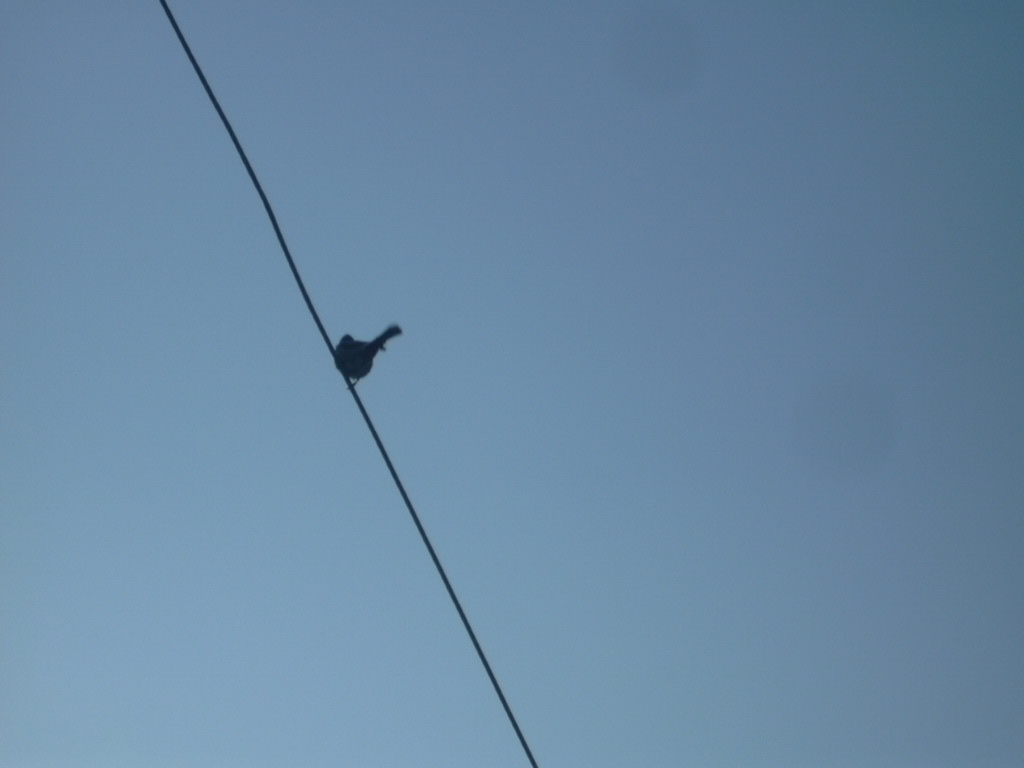Can you tell me what time of day this photo might have been taken? Given the bright sky and the angle of light suggesting a low sun, it could be either early in the morning or late in the afternoon. 